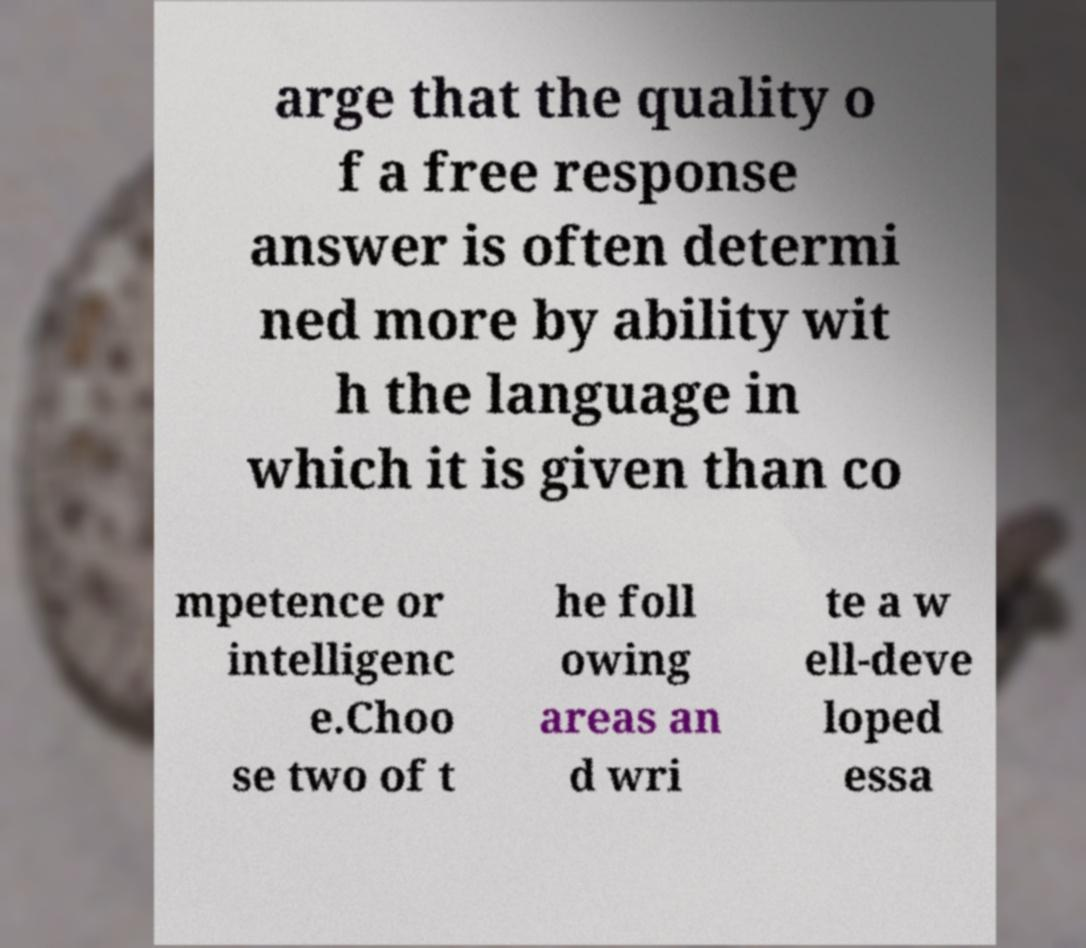There's text embedded in this image that I need extracted. Can you transcribe it verbatim? arge that the quality o f a free response answer is often determi ned more by ability wit h the language in which it is given than co mpetence or intelligenc e.Choo se two of t he foll owing areas an d wri te a w ell-deve loped essa 